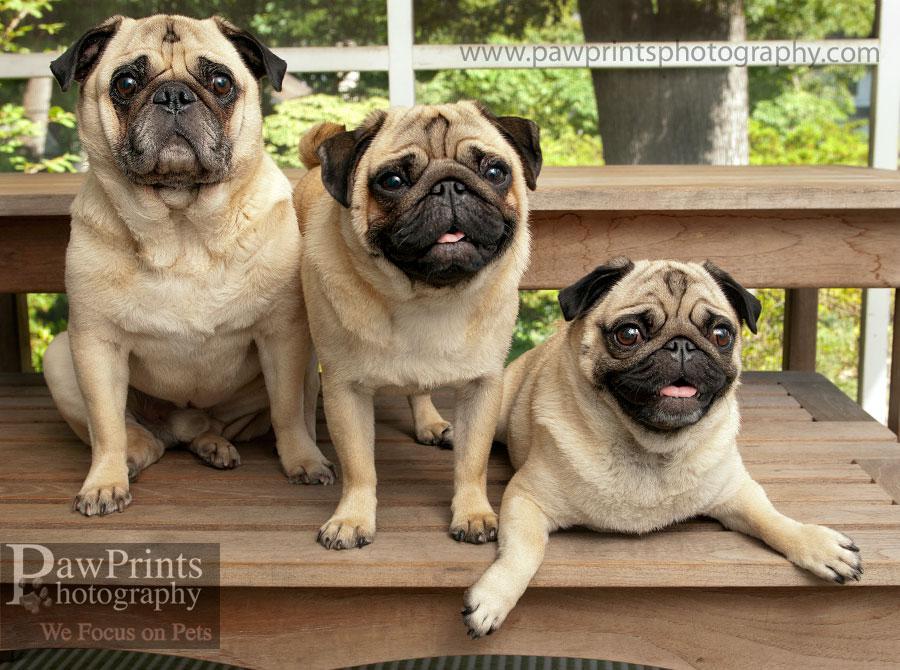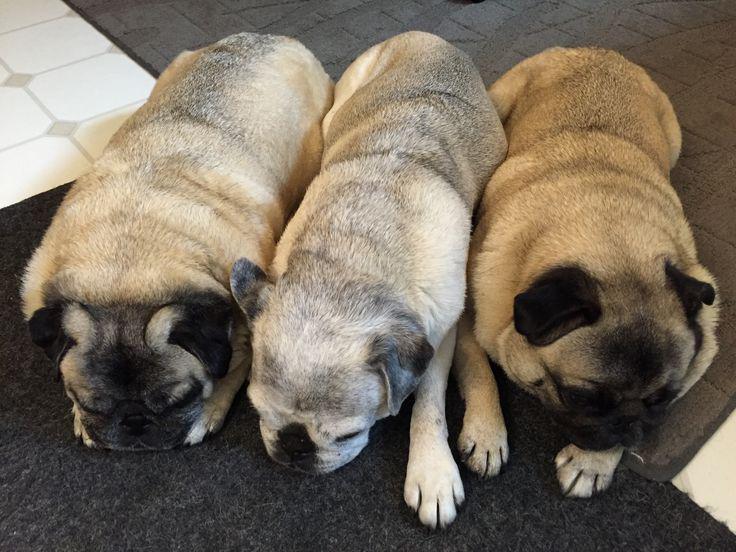The first image is the image on the left, the second image is the image on the right. Assess this claim about the two images: "An image contains three pug dogs on a wooden picnic table.". Correct or not? Answer yes or no. Yes. The first image is the image on the left, the second image is the image on the right. Given the left and right images, does the statement "Three dogs are on a wooden step in one of the images." hold true? Answer yes or no. Yes. 